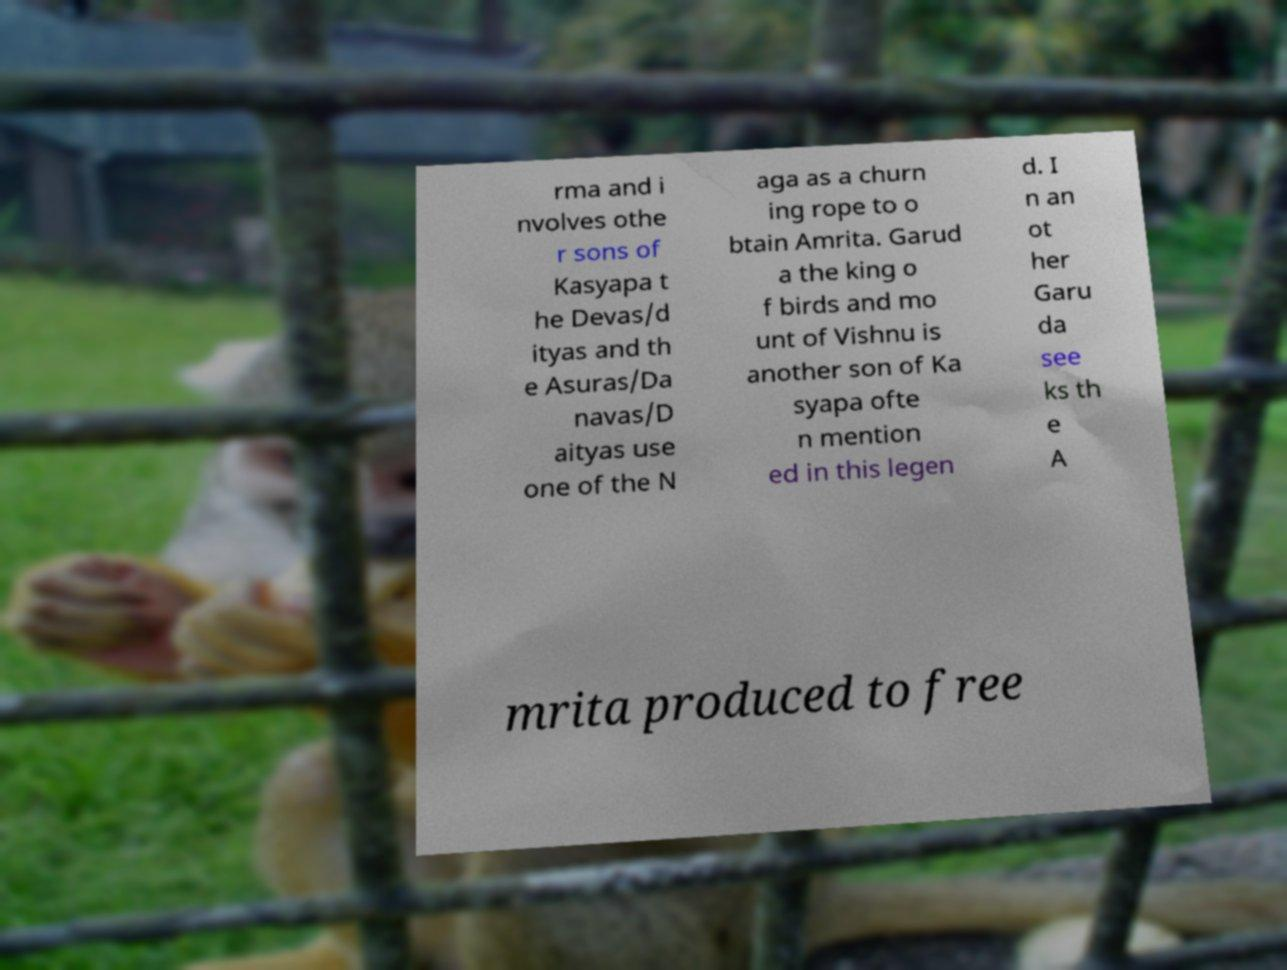Could you extract and type out the text from this image? rma and i nvolves othe r sons of Kasyapa t he Devas/d ityas and th e Asuras/Da navas/D aityas use one of the N aga as a churn ing rope to o btain Amrita. Garud a the king o f birds and mo unt of Vishnu is another son of Ka syapa ofte n mention ed in this legen d. I n an ot her Garu da see ks th e A mrita produced to free 